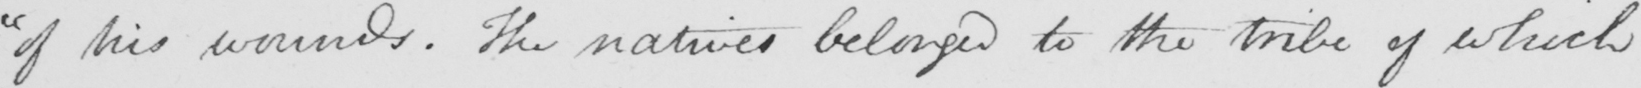Please provide the text content of this handwritten line. " of his wounds . The natives belonged to the tribe of which 